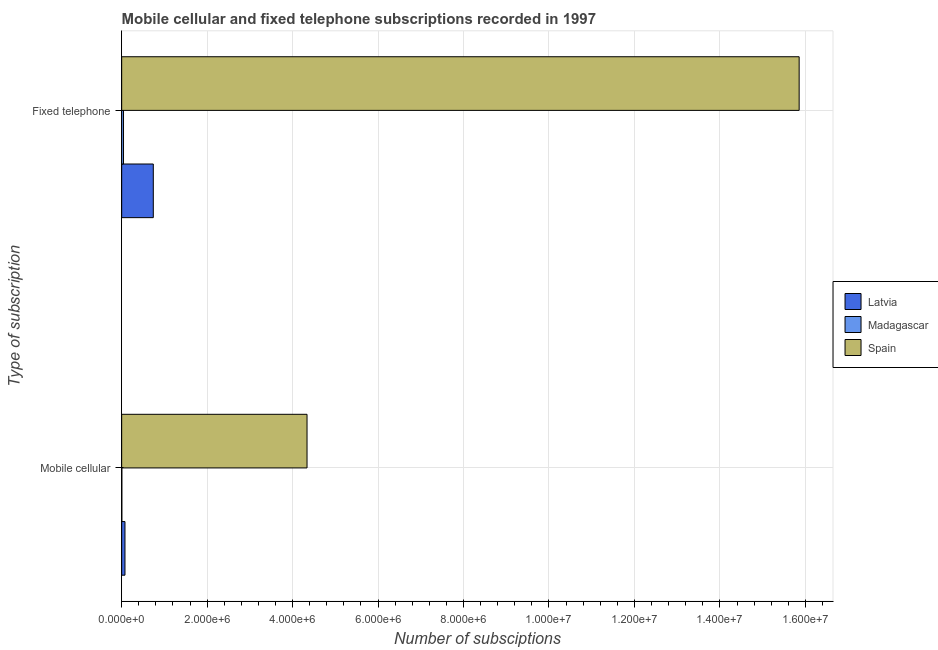How many different coloured bars are there?
Give a very brief answer. 3. Are the number of bars per tick equal to the number of legend labels?
Make the answer very short. Yes. How many bars are there on the 2nd tick from the top?
Your answer should be compact. 3. What is the label of the 1st group of bars from the top?
Give a very brief answer. Fixed telephone. What is the number of fixed telephone subscriptions in Latvia?
Offer a very short reply. 7.40e+05. Across all countries, what is the maximum number of mobile cellular subscriptions?
Provide a short and direct response. 4.34e+06. Across all countries, what is the minimum number of fixed telephone subscriptions?
Your answer should be compact. 4.32e+04. In which country was the number of mobile cellular subscriptions minimum?
Your answer should be very brief. Madagascar. What is the total number of fixed telephone subscriptions in the graph?
Your response must be concise. 1.66e+07. What is the difference between the number of fixed telephone subscriptions in Spain and that in Madagascar?
Your answer should be compact. 1.58e+07. What is the difference between the number of fixed telephone subscriptions in Latvia and the number of mobile cellular subscriptions in Madagascar?
Offer a very short reply. 7.36e+05. What is the average number of mobile cellular subscriptions per country?
Provide a short and direct response. 1.47e+06. What is the difference between the number of mobile cellular subscriptions and number of fixed telephone subscriptions in Spain?
Your answer should be compact. -1.15e+07. In how many countries, is the number of mobile cellular subscriptions greater than 10800000 ?
Keep it short and to the point. 0. What is the ratio of the number of mobile cellular subscriptions in Spain to that in Latvia?
Offer a very short reply. 56.26. What does the 3rd bar from the top in Mobile cellular represents?
Ensure brevity in your answer.  Latvia. What does the 2nd bar from the bottom in Mobile cellular represents?
Offer a very short reply. Madagascar. Are all the bars in the graph horizontal?
Your answer should be compact. Yes. What is the difference between two consecutive major ticks on the X-axis?
Ensure brevity in your answer.  2.00e+06. Are the values on the major ticks of X-axis written in scientific E-notation?
Make the answer very short. Yes. Does the graph contain grids?
Your response must be concise. Yes. How many legend labels are there?
Provide a short and direct response. 3. How are the legend labels stacked?
Make the answer very short. Vertical. What is the title of the graph?
Your answer should be very brief. Mobile cellular and fixed telephone subscriptions recorded in 1997. What is the label or title of the X-axis?
Offer a terse response. Number of subsciptions. What is the label or title of the Y-axis?
Offer a terse response. Type of subscription. What is the Number of subsciptions of Latvia in Mobile cellular?
Provide a succinct answer. 7.71e+04. What is the Number of subsciptions in Madagascar in Mobile cellular?
Provide a short and direct response. 4100. What is the Number of subsciptions in Spain in Mobile cellular?
Provide a succinct answer. 4.34e+06. What is the Number of subsciptions of Latvia in Fixed telephone?
Your response must be concise. 7.40e+05. What is the Number of subsciptions of Madagascar in Fixed telephone?
Make the answer very short. 4.32e+04. What is the Number of subsciptions of Spain in Fixed telephone?
Give a very brief answer. 1.59e+07. Across all Type of subscription, what is the maximum Number of subsciptions in Latvia?
Your response must be concise. 7.40e+05. Across all Type of subscription, what is the maximum Number of subsciptions of Madagascar?
Provide a short and direct response. 4.32e+04. Across all Type of subscription, what is the maximum Number of subsciptions of Spain?
Keep it short and to the point. 1.59e+07. Across all Type of subscription, what is the minimum Number of subsciptions of Latvia?
Provide a succinct answer. 7.71e+04. Across all Type of subscription, what is the minimum Number of subsciptions in Madagascar?
Your answer should be very brief. 4100. Across all Type of subscription, what is the minimum Number of subsciptions of Spain?
Offer a very short reply. 4.34e+06. What is the total Number of subsciptions of Latvia in the graph?
Keep it short and to the point. 8.17e+05. What is the total Number of subsciptions in Madagascar in the graph?
Offer a very short reply. 4.73e+04. What is the total Number of subsciptions of Spain in the graph?
Offer a very short reply. 2.02e+07. What is the difference between the Number of subsciptions of Latvia in Mobile cellular and that in Fixed telephone?
Provide a succinct answer. -6.63e+05. What is the difference between the Number of subsciptions in Madagascar in Mobile cellular and that in Fixed telephone?
Ensure brevity in your answer.  -3.91e+04. What is the difference between the Number of subsciptions in Spain in Mobile cellular and that in Fixed telephone?
Keep it short and to the point. -1.15e+07. What is the difference between the Number of subsciptions of Latvia in Mobile cellular and the Number of subsciptions of Madagascar in Fixed telephone?
Offer a very short reply. 3.39e+04. What is the difference between the Number of subsciptions of Latvia in Mobile cellular and the Number of subsciptions of Spain in Fixed telephone?
Offer a very short reply. -1.58e+07. What is the difference between the Number of subsciptions in Madagascar in Mobile cellular and the Number of subsciptions in Spain in Fixed telephone?
Provide a short and direct response. -1.59e+07. What is the average Number of subsciptions in Latvia per Type of subscription?
Provide a short and direct response. 4.09e+05. What is the average Number of subsciptions in Madagascar per Type of subscription?
Offer a terse response. 2.36e+04. What is the average Number of subsciptions in Spain per Type of subscription?
Keep it short and to the point. 1.01e+07. What is the difference between the Number of subsciptions of Latvia and Number of subsciptions of Madagascar in Mobile cellular?
Ensure brevity in your answer.  7.30e+04. What is the difference between the Number of subsciptions in Latvia and Number of subsciptions in Spain in Mobile cellular?
Your answer should be compact. -4.26e+06. What is the difference between the Number of subsciptions of Madagascar and Number of subsciptions of Spain in Mobile cellular?
Your answer should be very brief. -4.33e+06. What is the difference between the Number of subsciptions of Latvia and Number of subsciptions of Madagascar in Fixed telephone?
Make the answer very short. 6.97e+05. What is the difference between the Number of subsciptions of Latvia and Number of subsciptions of Spain in Fixed telephone?
Give a very brief answer. -1.51e+07. What is the difference between the Number of subsciptions of Madagascar and Number of subsciptions of Spain in Fixed telephone?
Provide a short and direct response. -1.58e+07. What is the ratio of the Number of subsciptions of Latvia in Mobile cellular to that in Fixed telephone?
Keep it short and to the point. 0.1. What is the ratio of the Number of subsciptions in Madagascar in Mobile cellular to that in Fixed telephone?
Ensure brevity in your answer.  0.09. What is the ratio of the Number of subsciptions in Spain in Mobile cellular to that in Fixed telephone?
Keep it short and to the point. 0.27. What is the difference between the highest and the second highest Number of subsciptions of Latvia?
Your response must be concise. 6.63e+05. What is the difference between the highest and the second highest Number of subsciptions in Madagascar?
Offer a very short reply. 3.91e+04. What is the difference between the highest and the second highest Number of subsciptions of Spain?
Your response must be concise. 1.15e+07. What is the difference between the highest and the lowest Number of subsciptions in Latvia?
Keep it short and to the point. 6.63e+05. What is the difference between the highest and the lowest Number of subsciptions in Madagascar?
Ensure brevity in your answer.  3.91e+04. What is the difference between the highest and the lowest Number of subsciptions of Spain?
Your answer should be compact. 1.15e+07. 